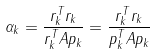Convert formula to latex. <formula><loc_0><loc_0><loc_500><loc_500>\alpha _ { k } = { \frac { r _ { k } ^ { T } r _ { k } } { r _ { k } ^ { T } A p _ { k } } } = { \frac { r _ { k } ^ { T } r _ { k } } { p _ { k } ^ { T } A p _ { k } } }</formula> 